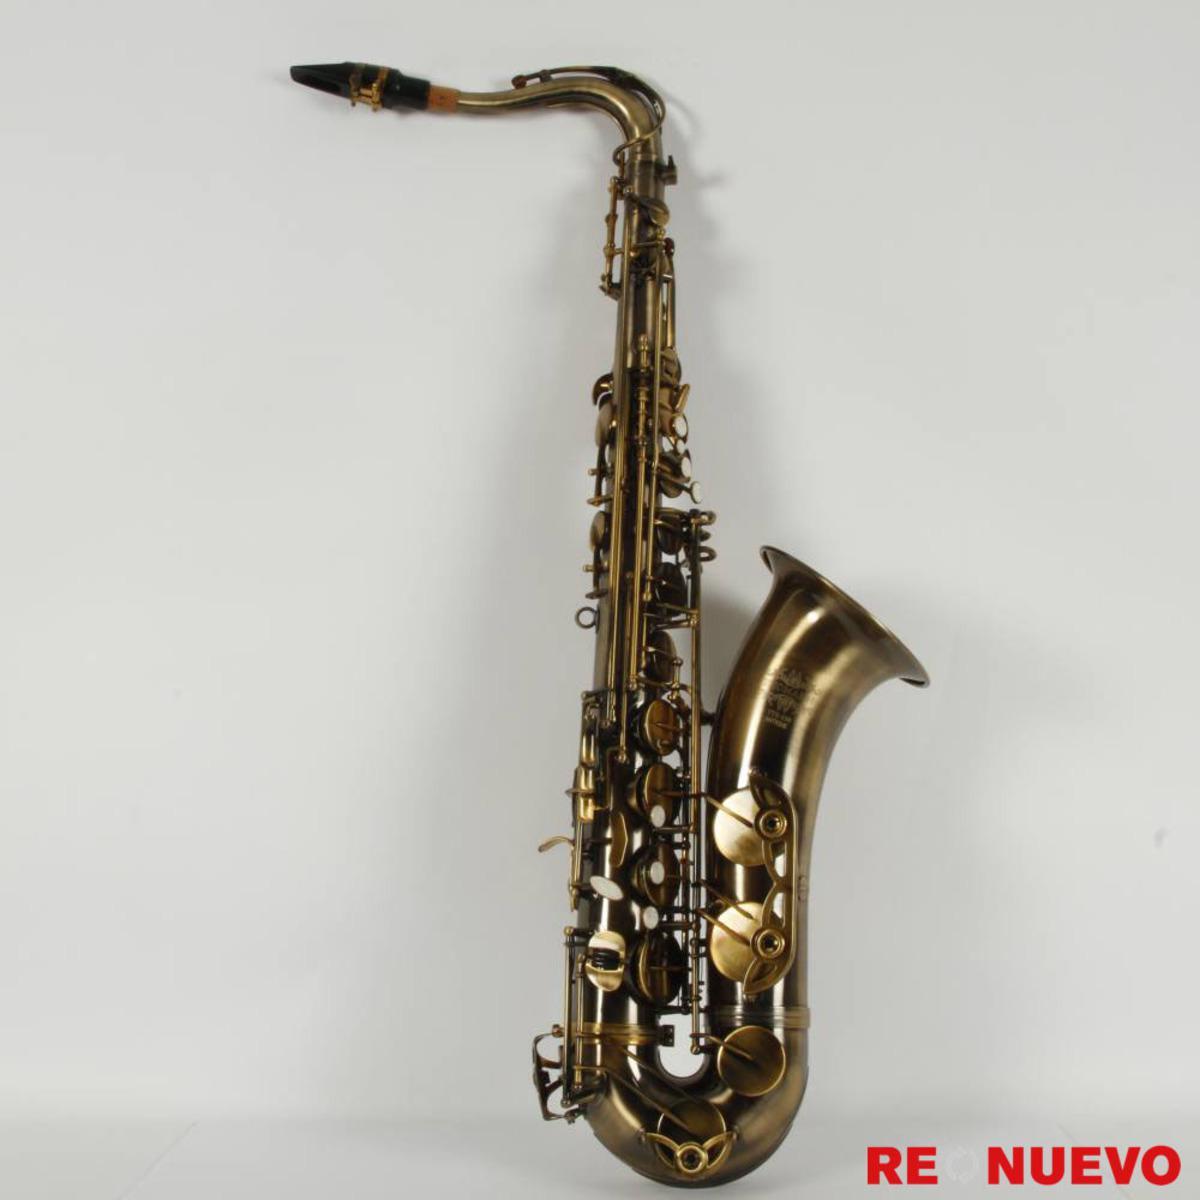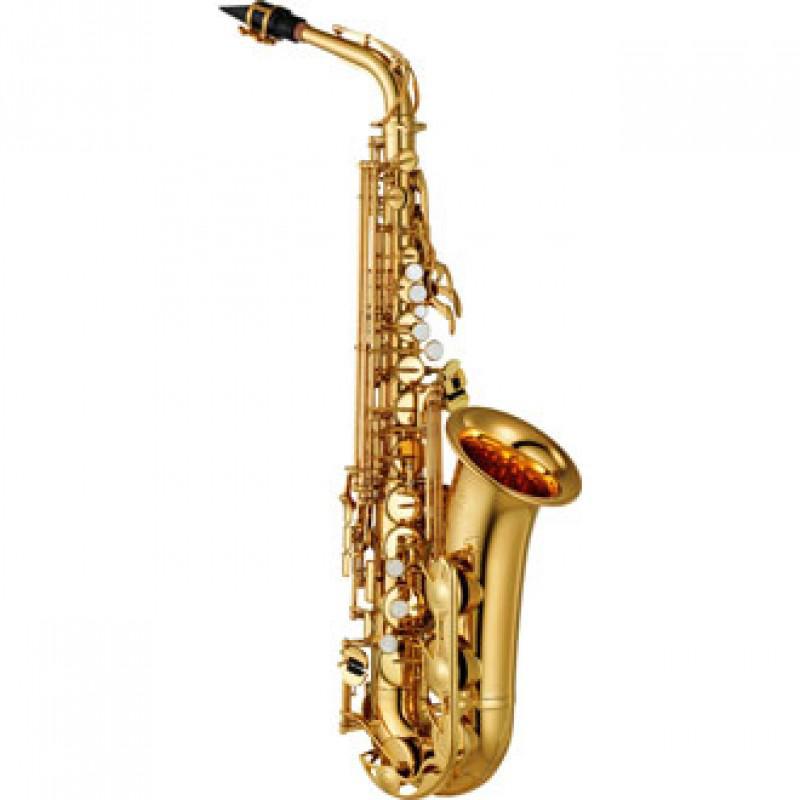The first image is the image on the left, the second image is the image on the right. Analyze the images presented: Is the assertion "The saxophone in one of the images is against a solid white background." valid? Answer yes or no. Yes. 